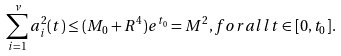Convert formula to latex. <formula><loc_0><loc_0><loc_500><loc_500>\sum _ { i = 1 } ^ { \nu } a _ { i } ^ { 2 } ( t ) \leq ( M _ { 0 } + R ^ { 4 } ) e ^ { t _ { 0 } } = M ^ { 2 } , f o r a l l t \in [ 0 , t _ { 0 } ] .</formula> 